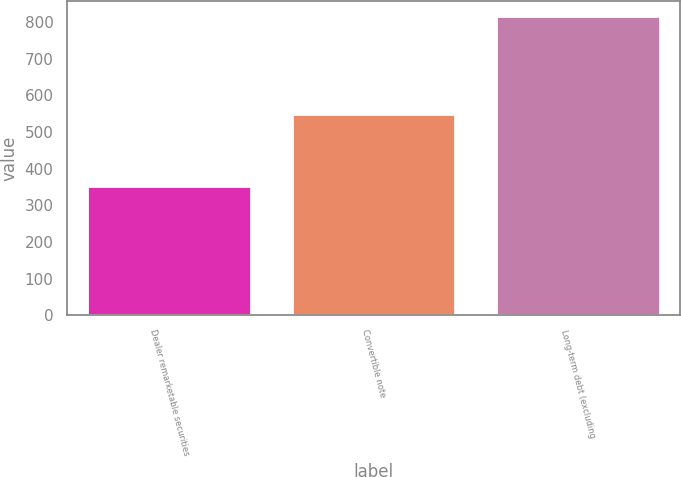Convert chart. <chart><loc_0><loc_0><loc_500><loc_500><bar_chart><fcel>Dealer remarketable securities<fcel>Convertible note<fcel>Long-term debt (excluding<nl><fcel>352<fcel>549<fcel>816<nl></chart> 